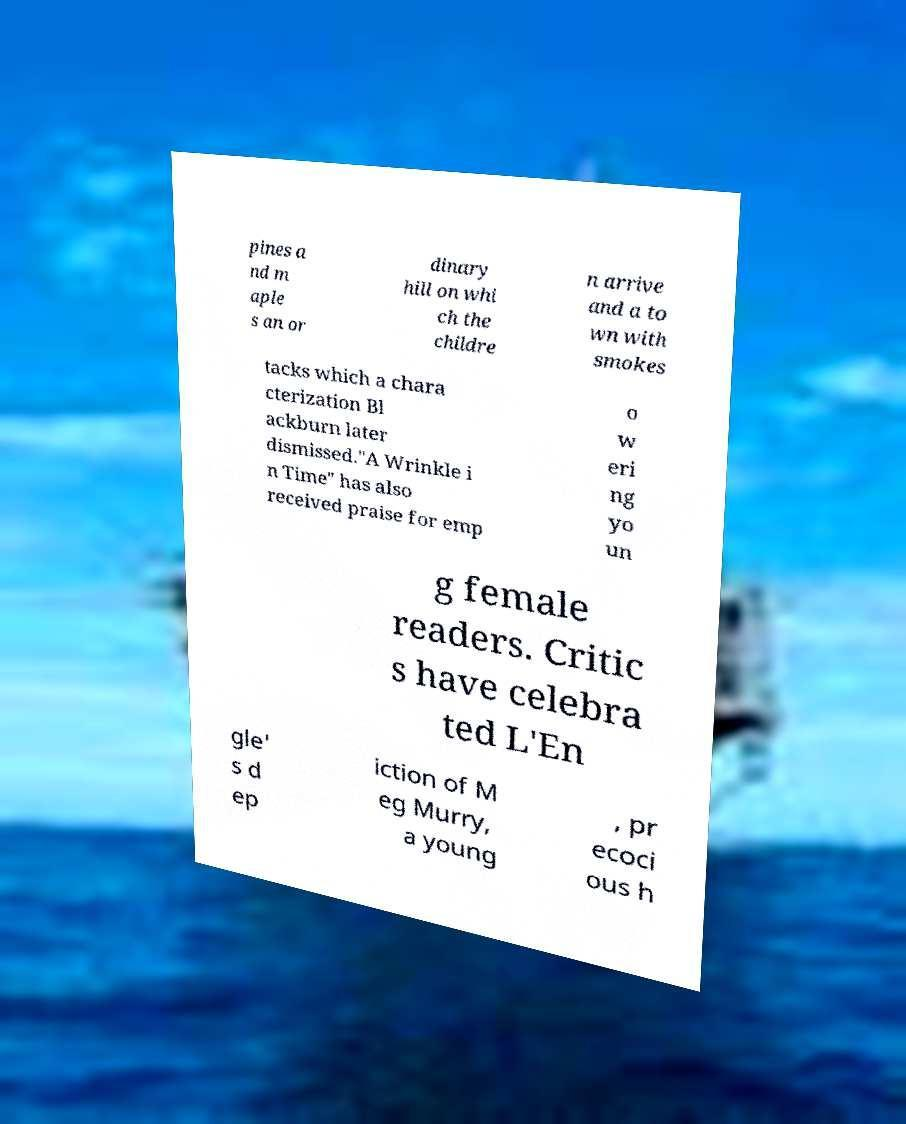What messages or text are displayed in this image? I need them in a readable, typed format. pines a nd m aple s an or dinary hill on whi ch the childre n arrive and a to wn with smokes tacks which a chara cterization Bl ackburn later dismissed."A Wrinkle i n Time" has also received praise for emp o w eri ng yo un g female readers. Critic s have celebra ted L'En gle' s d ep iction of M eg Murry, a young , pr ecoci ous h 